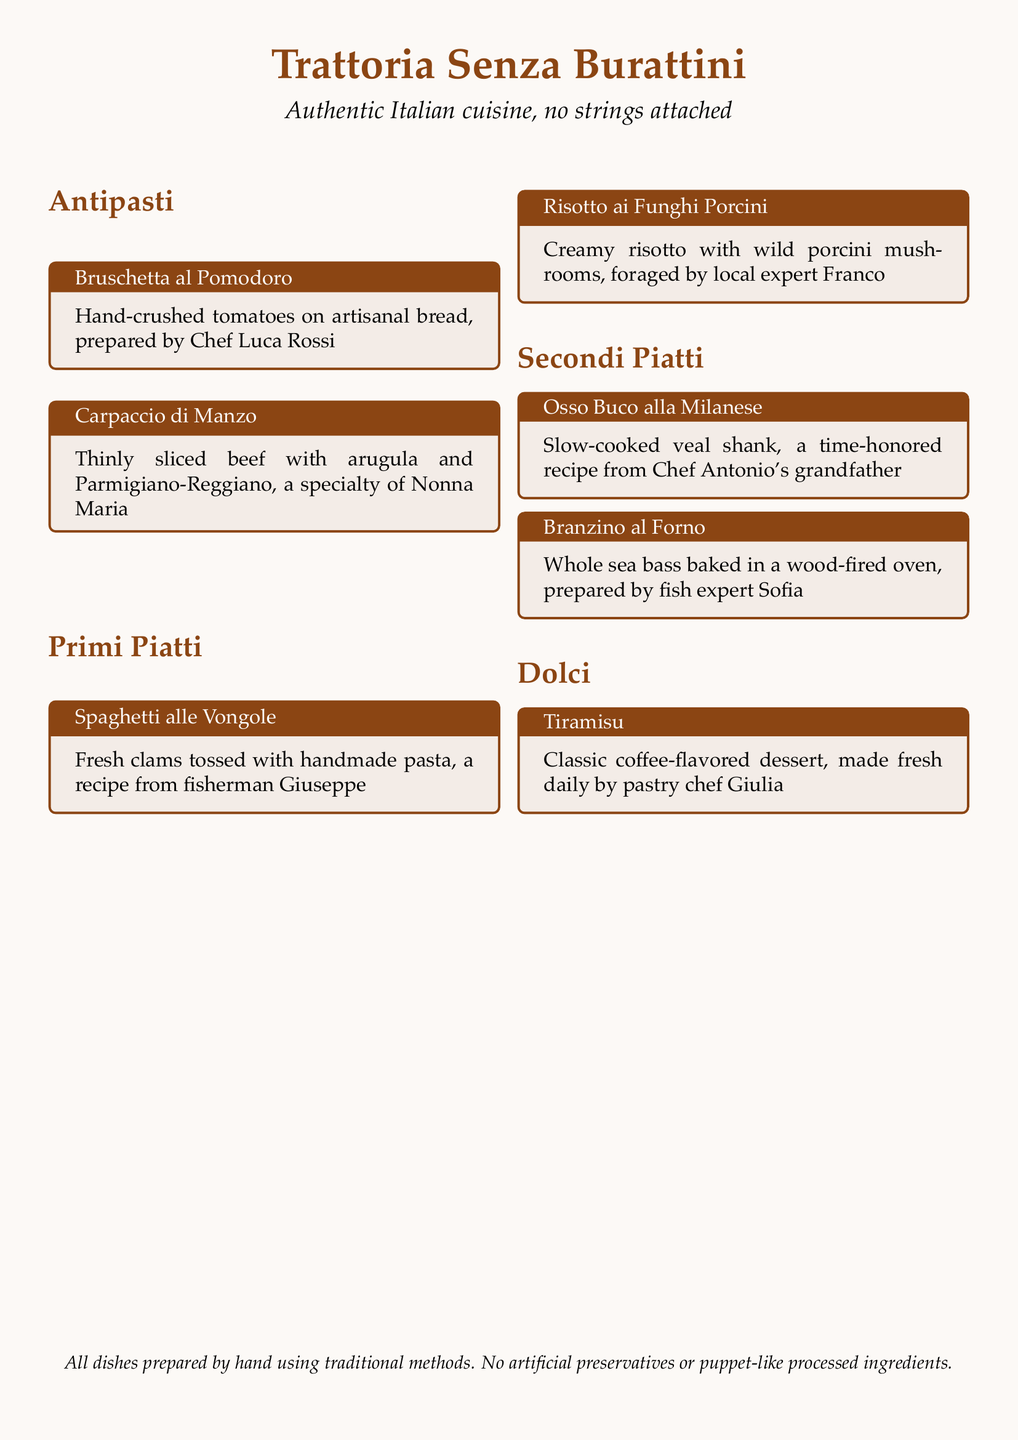What is the name of the trattoria? The name is directly stated in the title at the top of the menu.
Answer: Trattoria Senza Burattini Who prepared the Bruschetta al Pomodoro? The chef responsible for this dish is mentioned in the box for the Bruschetta.
Answer: Chef Luca Rossi What type of seafood is used in the Spaghetti alle Vongole? The main ingredient, which is given in the description, is a type of shellfish.
Answer: Clams What is the specialty of Nonna Maria? Nonna Maria's specialty is highlighted in the description under the Antipasti section.
Answer: Carpaccio di Manzo What method is used to bake the Branzino al Forno? The cooking method is specified in the description of the Branzino dish.
Answer: Wood-fired oven Which dish features wild porcini mushrooms? The dish that includes these mushrooms is identified under the Primi Piatti section.
Answer: Risotto ai Funghi Porcini Who is responsible for making the Tiramisu? The pastry chef associated with this dessert is mentioned in the Dolci section.
Answer: Pastry chef Giulia What is the key feature of all dishes at the trattoria? A unique aspect emphasized in the menu is mentioned towards the end of the document.
Answer: Traditional methods 